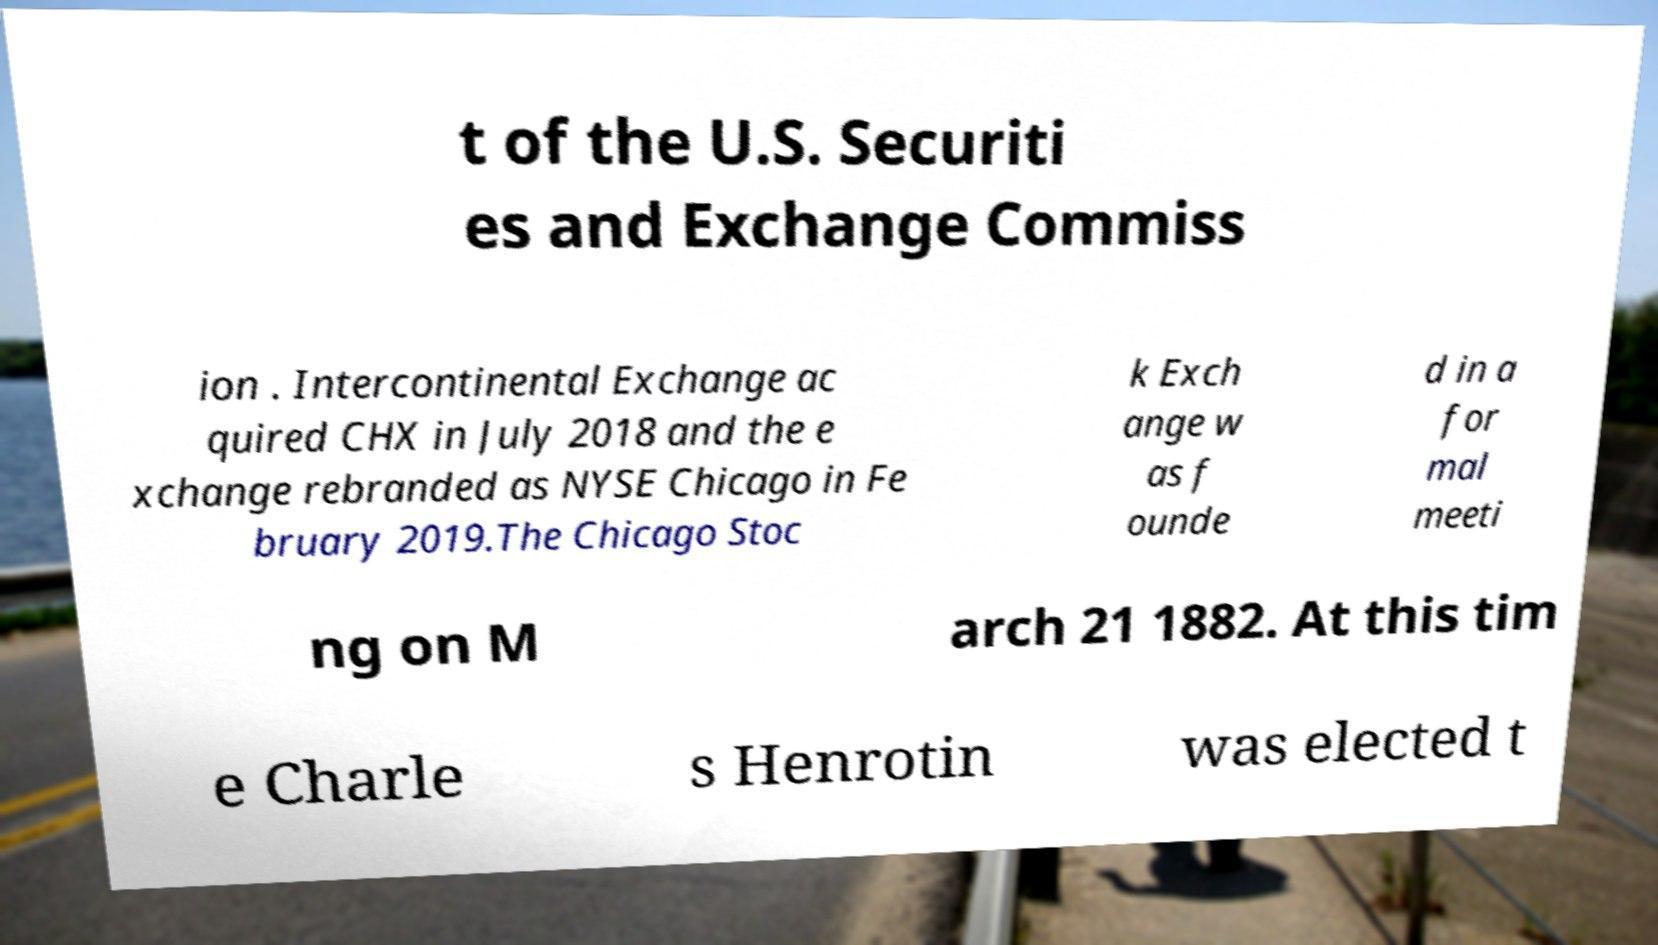Please identify and transcribe the text found in this image. t of the U.S. Securiti es and Exchange Commiss ion . Intercontinental Exchange ac quired CHX in July 2018 and the e xchange rebranded as NYSE Chicago in Fe bruary 2019.The Chicago Stoc k Exch ange w as f ounde d in a for mal meeti ng on M arch 21 1882. At this tim e Charle s Henrotin was elected t 